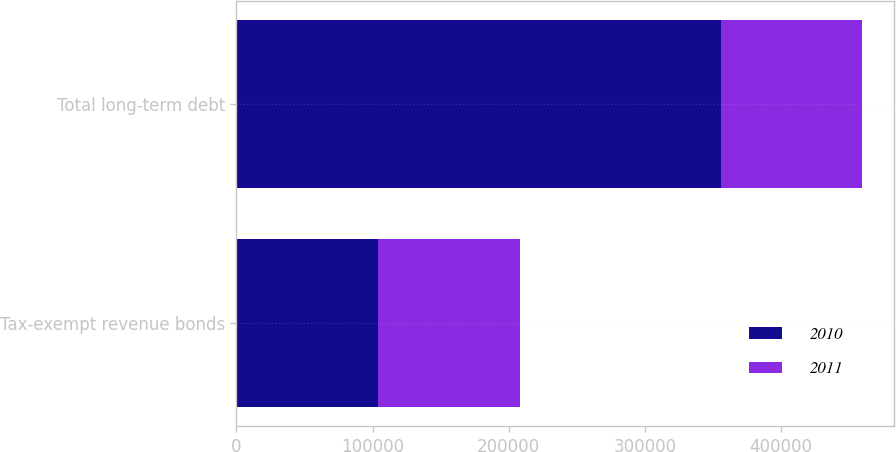<chart> <loc_0><loc_0><loc_500><loc_500><stacked_bar_chart><ecel><fcel>Tax-exempt revenue bonds<fcel>Total long-term debt<nl><fcel>2010<fcel>104095<fcel>355683<nl><fcel>2011<fcel>104095<fcel>104095<nl></chart> 